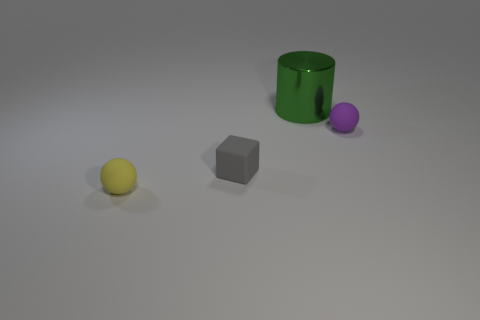How many things are objects in front of the green object or small red metallic things?
Provide a short and direct response. 3. Is the number of big green metal objects behind the tiny yellow matte ball less than the number of objects that are behind the rubber block?
Keep it short and to the point. Yes. What number of other things are there of the same size as the cylinder?
Offer a terse response. 0. Is the yellow sphere made of the same material as the thing on the right side of the large metallic cylinder?
Your answer should be very brief. Yes. How many things are rubber balls left of the tiny purple sphere or yellow rubber objects that are in front of the green metallic thing?
Offer a very short reply. 1. What color is the large cylinder?
Offer a very short reply. Green. Are there fewer tiny matte balls right of the matte cube than rubber balls?
Keep it short and to the point. Yes. Are there any other things that have the same shape as the metallic thing?
Your answer should be compact. No. Is there a gray metallic thing?
Make the answer very short. No. Are there fewer small yellow spheres than tiny cyan metal spheres?
Ensure brevity in your answer.  No. 